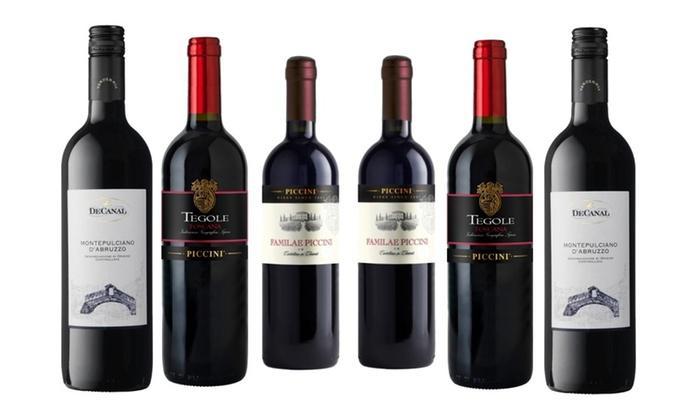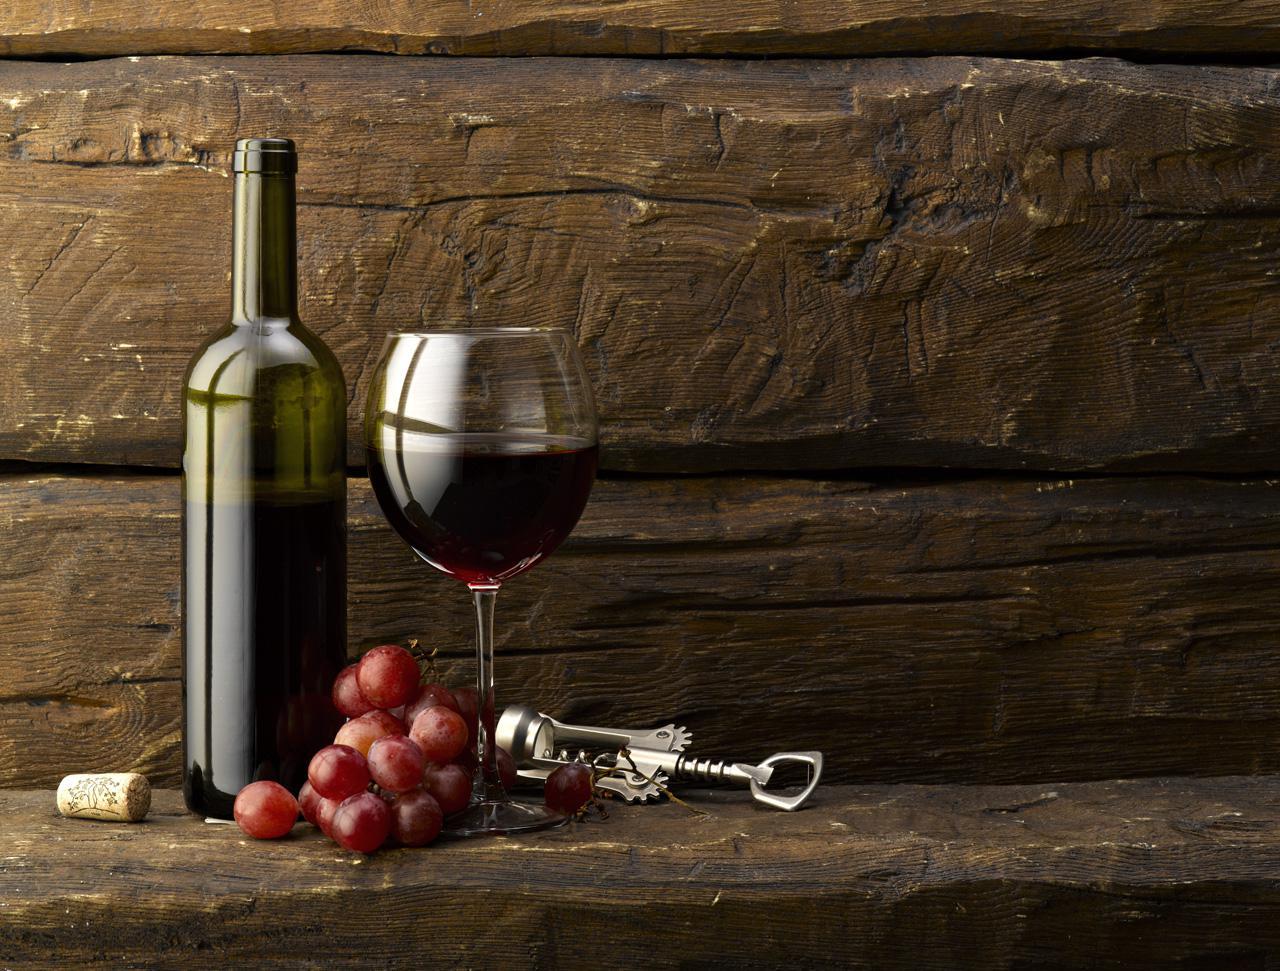The first image is the image on the left, the second image is the image on the right. For the images shown, is this caption "A single bottle and glass of wine are in one of the images." true? Answer yes or no. Yes. The first image is the image on the left, the second image is the image on the right. Examine the images to the left and right. Is the description "There is a glass of red wine next to a bottle of wine in one of the images" accurate? Answer yes or no. Yes. 